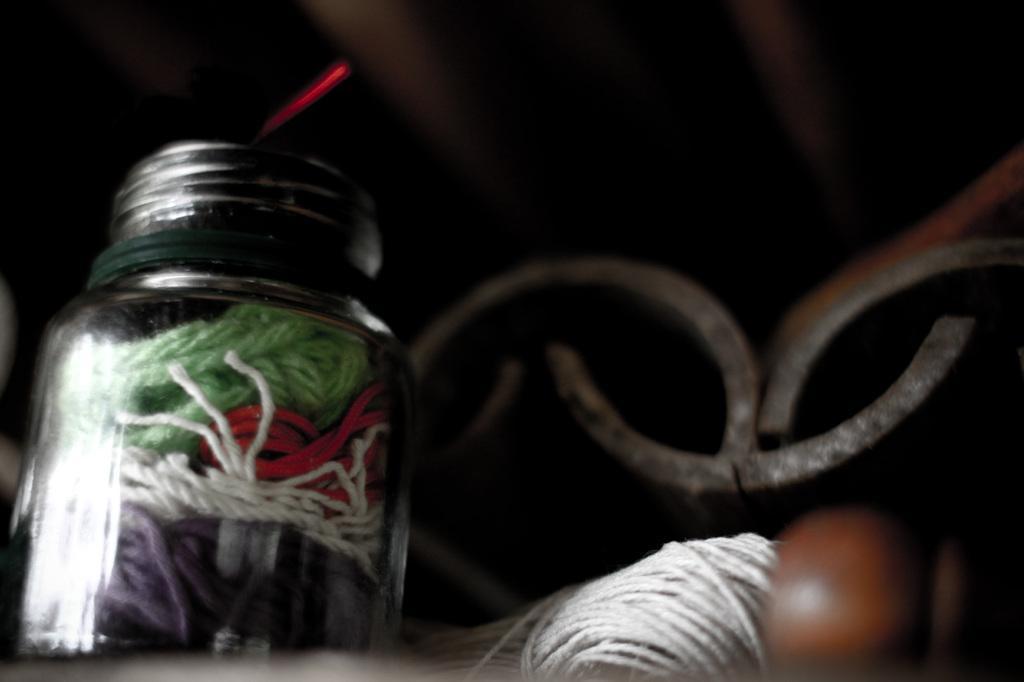How would you summarize this image in a sentence or two? In this image we can see a glass bottle. Inside the bottle colorful threads are there. Right side of the image white color thread bundle and metal is present. 